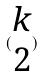<formula> <loc_0><loc_0><loc_500><loc_500>( \begin{matrix} k \\ 2 \end{matrix} )</formula> 